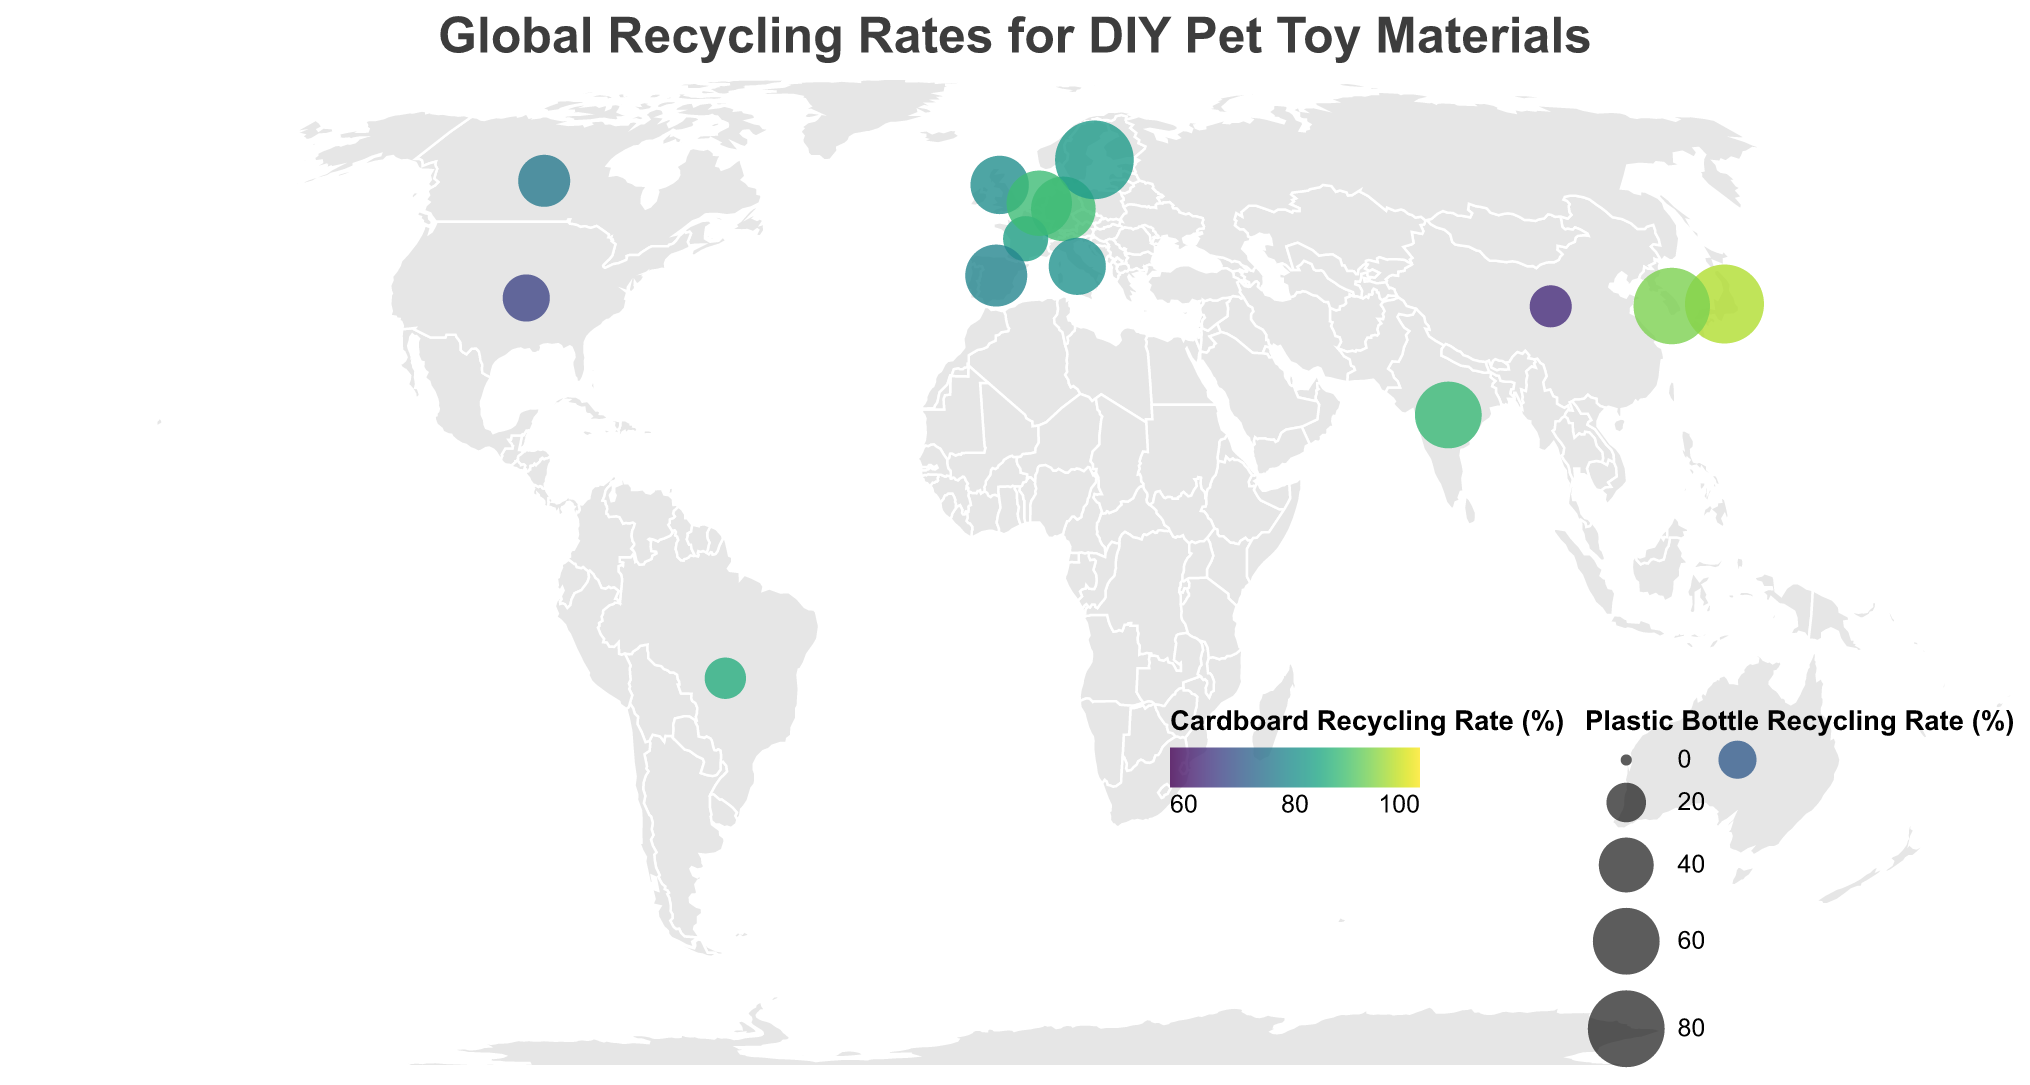Which country has the highest plastic bottle recycling rate? In the legend for Plastic Bottle Recycling Rate, the largest bubble size represents the highest rate. By observing the bubble sizes, Japan has the largest one, indicating the highest rate.
Answer: Japan What are the recycling rates for plastic bottles and cardboard in Brazil? By hovering over the data point for Brazil on the map, the tooltip provides the values: Plastic Bottle Recycling Rate of 22.0% and Cardboard Recycling Rate of 85.0%.
Answer: 22.0% for plastic bottles, 85.0% for cardboard Among Germany, France, and Italy, which country has the highest cardboard recycling rate? Observe the tooltip information for Germany, France, and Italy. Germany shows 87.7%, France displays 82.9%, and Italy shows 80.2%. Germany has the highest rate among the three.
Answer: Germany What is the difference in plastic bottle recycling rates between Sweden and the United States? Find the scrap rates from the tooltips: Sweden has 84.1% and the United States has 29.1%. Subtract the smaller from the larger: 84.1% - 29.1% = 55.0%.
Answer: 55.0% How many countries have a cardboard recycling rate of over 80% but below 90%? Identify the countries with a cardboard recycling rate between 80% and 90% by examining the legend color scheme and the map tooltips. The countries that meet this criteria are Germany, Brazil, France, Italy, and Sweden. Count these countries.
Answer: 5 Which country in Asia has the lowest plastic bottle recycling rate? By referring to the map and tooltips for countries in Asia, China has a plastic bottle recycling rate of 22.8%, which is lower compared to Japan (84.8%) and South Korea (79.3%).
Answer: China Which region appears to have generally higher recycling rates for both materials, Europe or Asia? Highlighted by the size of the bubbles and colors, observing European and Asian countries indicates that Europe (Germany, Netherlands, Sweden, etc.) generally shows higher recycling rates compared to Asian countries (India and China) except Japan and South Korea.
Answer: Europe Compare the plastic bottle recycling rate of India to the global average. Is India above or below the average? Calculate the global average by summing all countries' rates and dividing by the number of countries. The sum is 729.6 and there are 15 countries, so the average is 729.6/15 ≈ 48.6%. India's rate is 60%, which is above the average.
Answer: Above the average Which of the following countries, France or Canada, has a higher cardboard recycling rate and by how much? By checking the tooltips, France's rate is 82.9% and Canada's rate is 76.4%. The difference is 82.9% - 76.4% = 6.5%.
Answer: France by 6.5% 